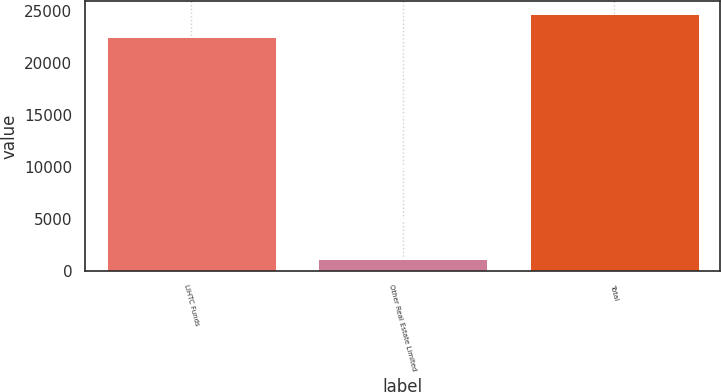Convert chart to OTSL. <chart><loc_0><loc_0><loc_500><loc_500><bar_chart><fcel>LIHTC Funds<fcel>Other Real Estate Limited<fcel>Total<nl><fcel>22501<fcel>1145<fcel>24752.4<nl></chart> 